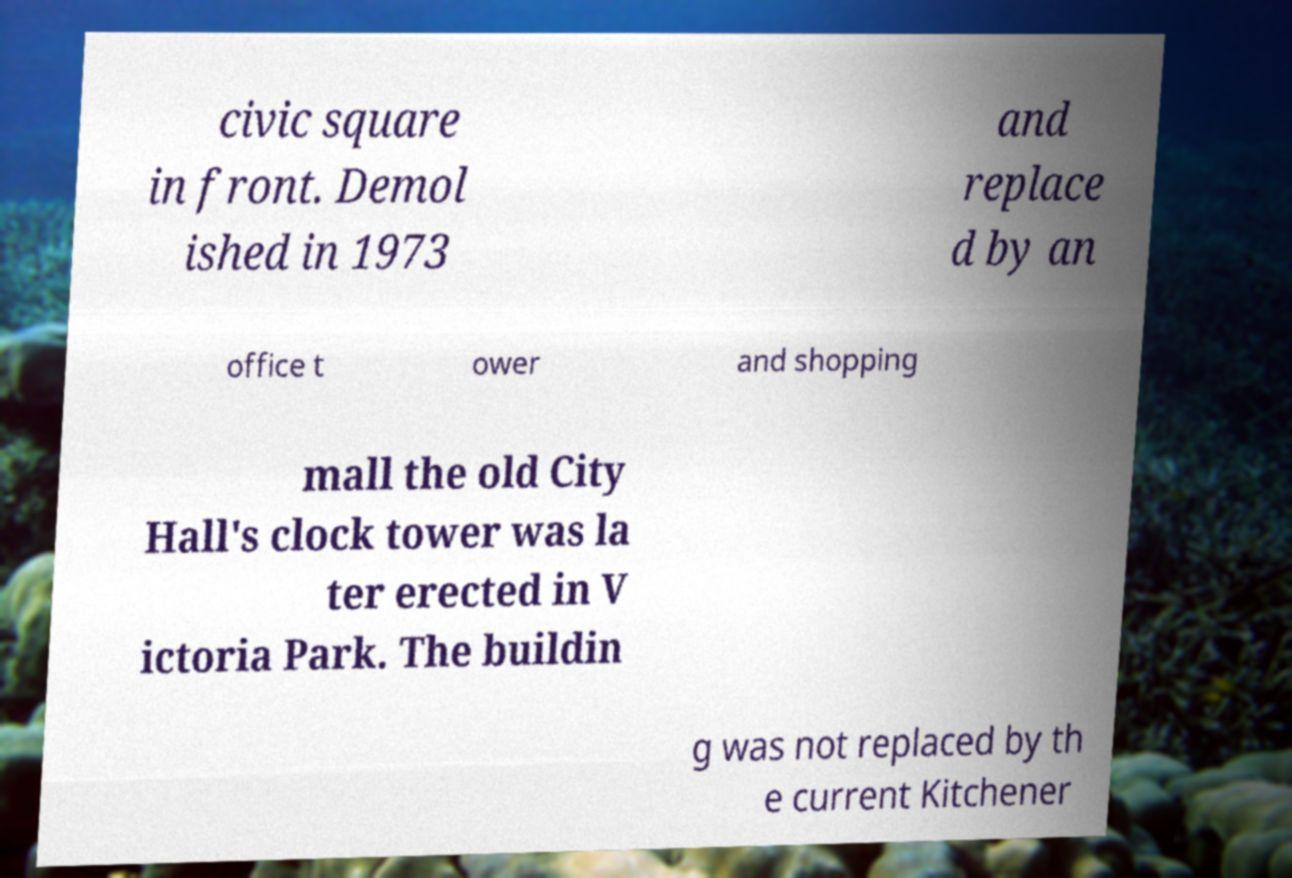What messages or text are displayed in this image? I need them in a readable, typed format. civic square in front. Demol ished in 1973 and replace d by an office t ower and shopping mall the old City Hall's clock tower was la ter erected in V ictoria Park. The buildin g was not replaced by th e current Kitchener 